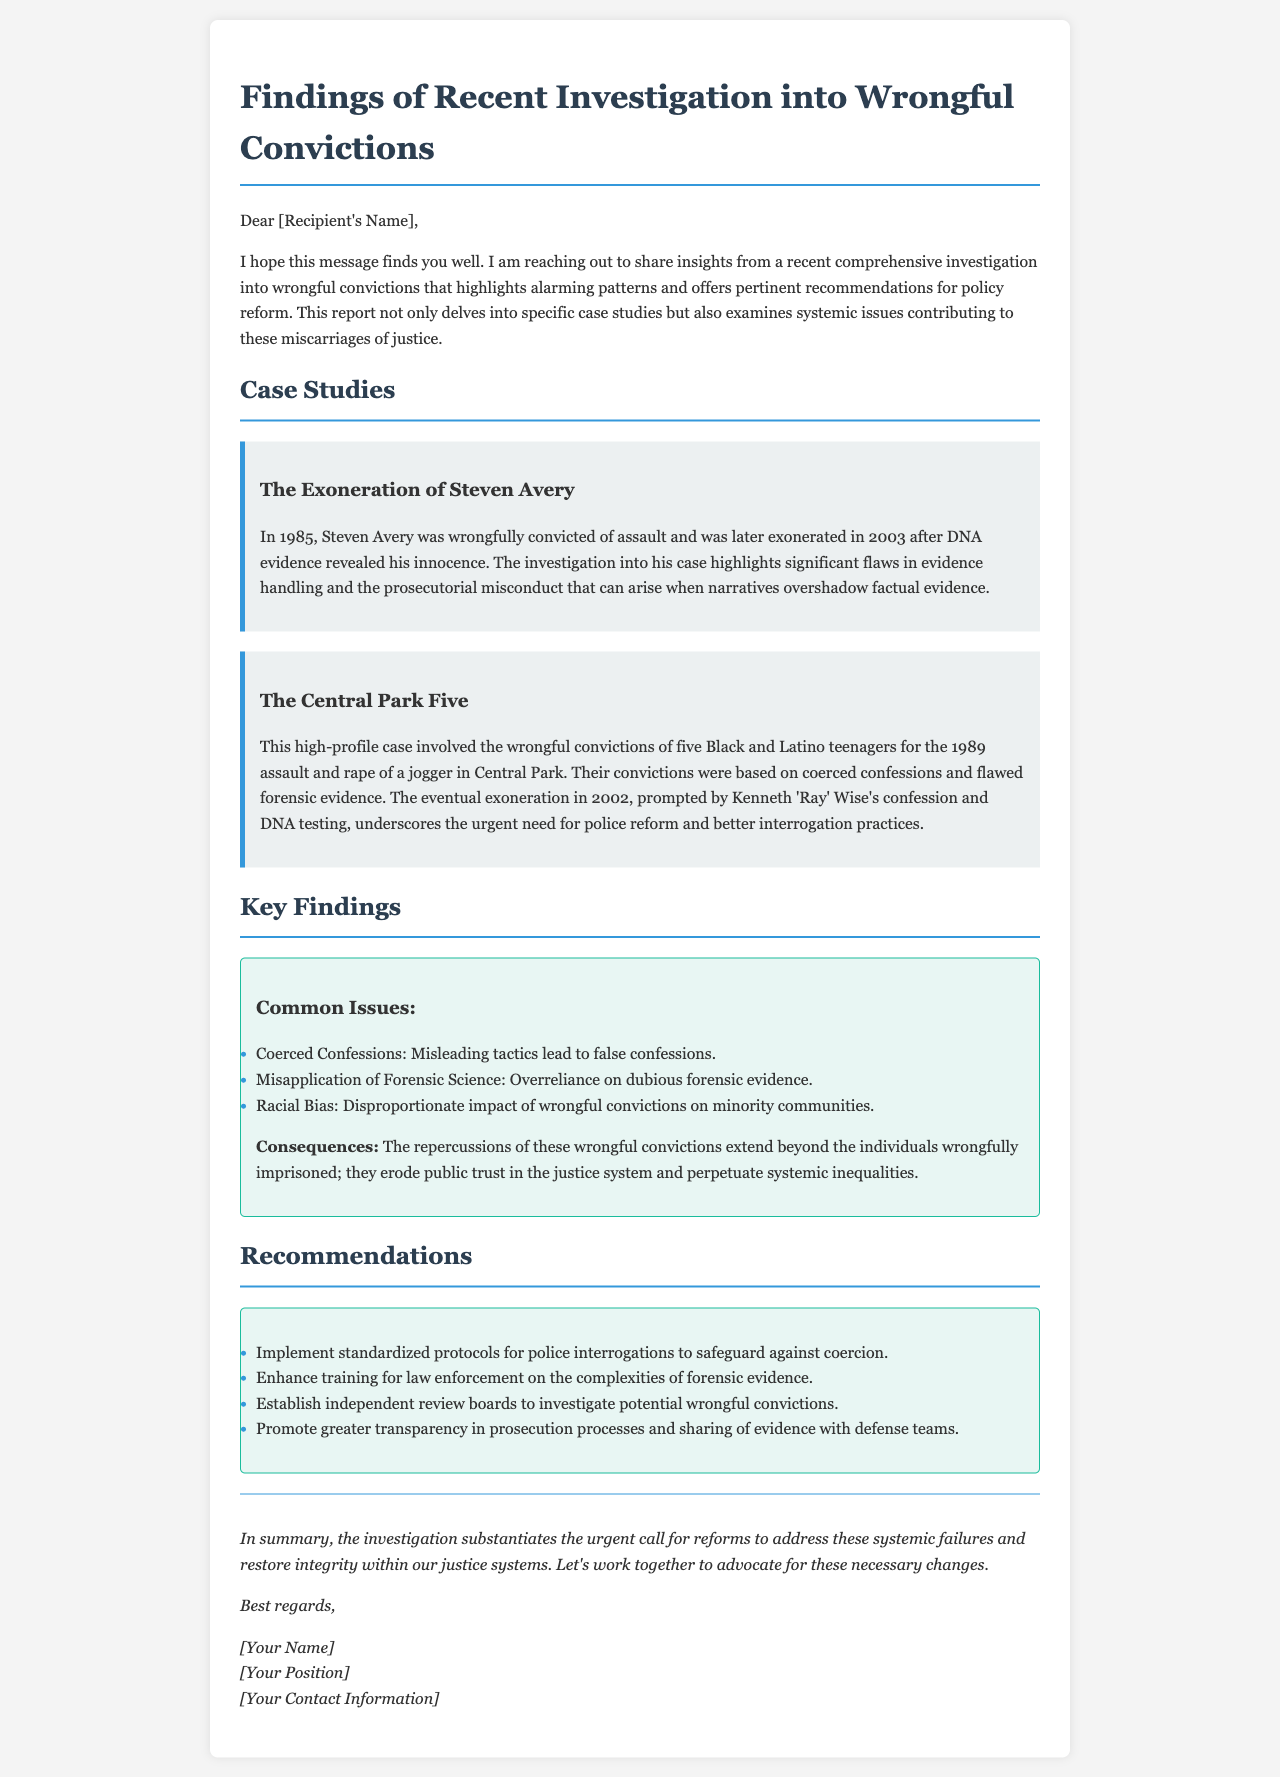What is the title of the report? The title of the report is "Findings of Recent Investigation into Wrongful Convictions."
Answer: Findings of Recent Investigation into Wrongful Convictions Who was wrongfully convicted in 1985? The individual wrongfully convicted in 1985 was Steven Avery.
Answer: Steven Avery In what year were the Central Park Five exonerated? The Central Park Five were exonerated in 2002.
Answer: 2002 What is one of the common issues identified in the findings? One of the common issues identified is "Coerced Confessions."
Answer: Coerced Confessions What is one recommended reform for police practices? One recommended reform is to "Implement standardized protocols for police interrogations."
Answer: Implement standardized protocols for police interrogations What type of evidence led to Steven Avery's exoneration? Steven Avery was exonerated after DNA evidence revealed his innocence.
Answer: DNA evidence What does the report suggest about the impact of wrongful convictions? The report suggests that the repercussions "erode public trust in the justice system."
Answer: Erode public trust in the justice system What is the primary purpose of this document? The primary purpose is to share insights from a recent investigation into wrongful convictions and recommend policy reform.
Answer: Share insights and recommend policy reform 